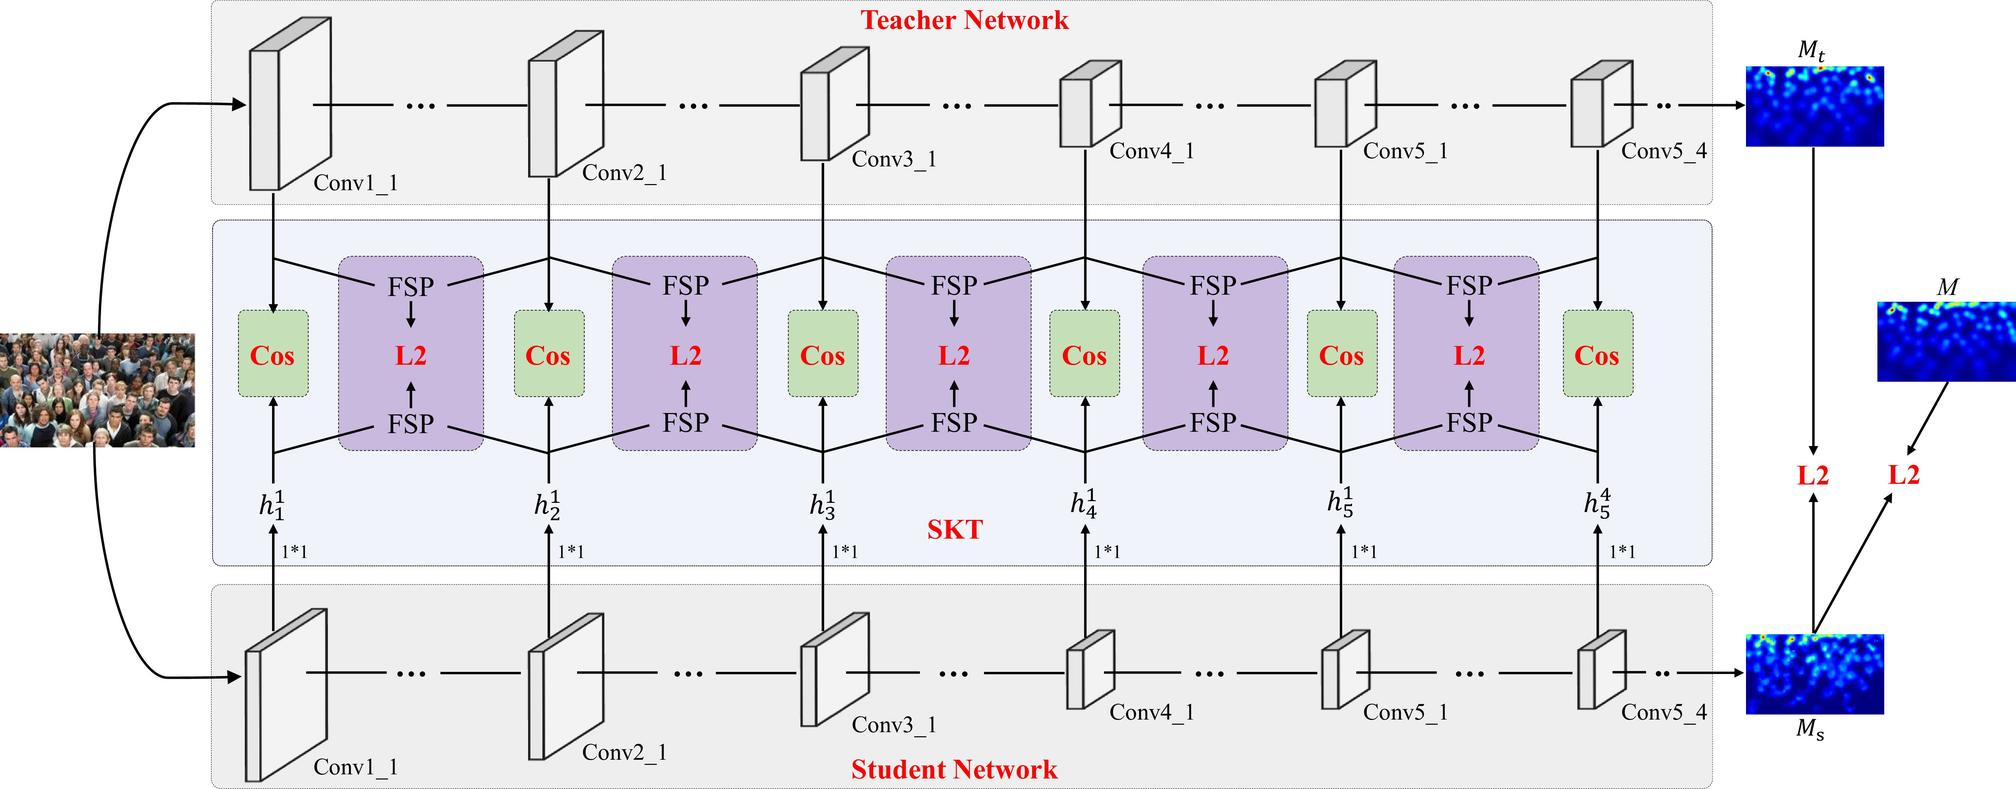What might be the role of the 'SKT' module as indicated in this diagram? While 'SKT' is not a standard acronym commonly recognized in the context of neural networks, based on its position in the diagram it could hypothetically refer to a 'Soft Knowledge Transfer' module or some similar concept. In this setup, 'SKT' may be an intermediate process that facilitates a softer, more gradual transfer of knowledge compared to the direct comparison using 'FSP' and cosine similarity. This could involve mechanisms like temperature-scaled soft targets, where the logits—or the non-normalized predictions—from the teacher network are softened before being used as targets for the student network's training. These softened targets can potentially provide richer information about the probability distribution over classes, enabling the student network to learn generalized features more effectively than from hard targets alone. 